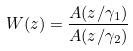<formula> <loc_0><loc_0><loc_500><loc_500>W ( z ) = \frac { A ( z / \gamma _ { 1 } ) } { A ( z / \gamma _ { 2 } ) }</formula> 